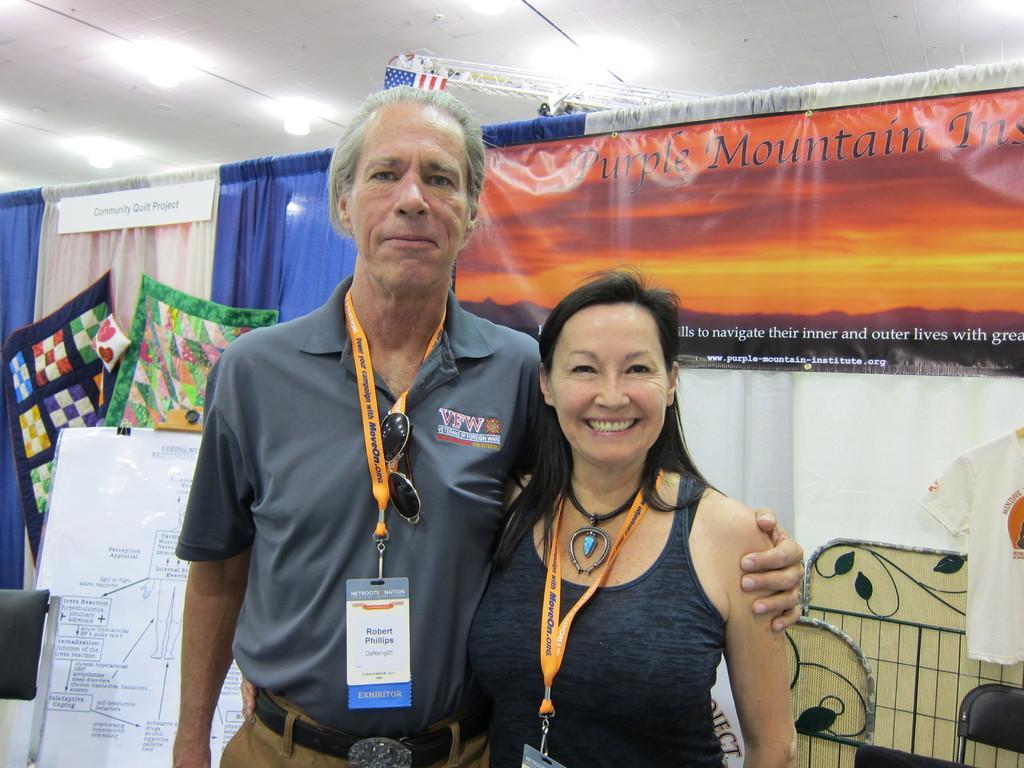Can you describe this image briefly? In the center of the image there is a man and woman standing. In the background we can see board, wall, clothes, curtain, poster, t-shirt and chair. 